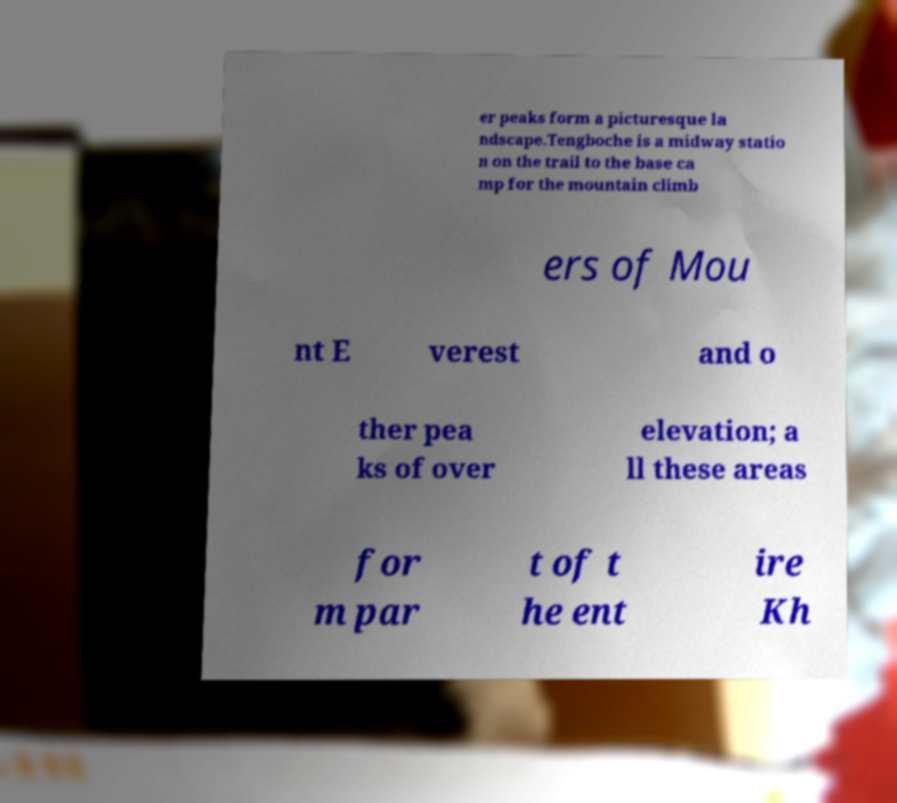Please identify and transcribe the text found in this image. er peaks form a picturesque la ndscape.Tengboche is a midway statio n on the trail to the base ca mp for the mountain climb ers of Mou nt E verest and o ther pea ks of over elevation; a ll these areas for m par t of t he ent ire Kh 